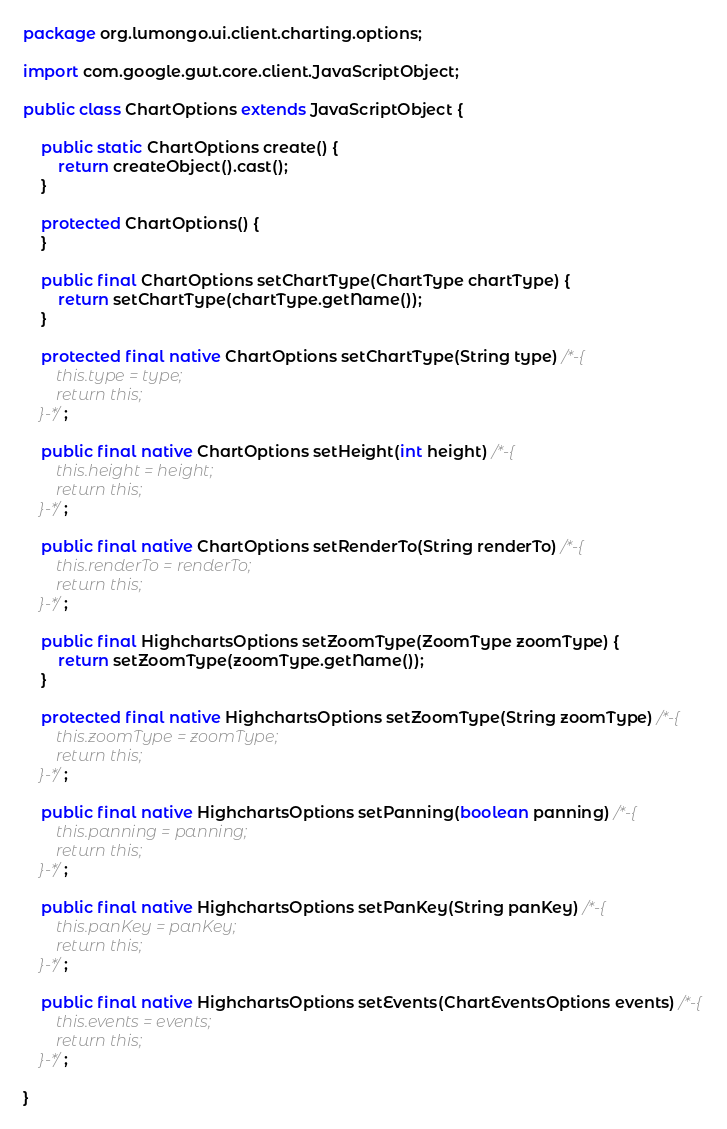Convert code to text. <code><loc_0><loc_0><loc_500><loc_500><_Java_>package org.lumongo.ui.client.charting.options;

import com.google.gwt.core.client.JavaScriptObject;

public class ChartOptions extends JavaScriptObject {

	public static ChartOptions create() {
		return createObject().cast();
	}

	protected ChartOptions() {
	}

	public final ChartOptions setChartType(ChartType chartType) {
		return setChartType(chartType.getName());
	}

	protected final native ChartOptions setChartType(String type) /*-{
        this.type = type;
        return this;
    }-*/;

	public final native ChartOptions setHeight(int height) /*-{
        this.height = height;
        return this;
    }-*/;

	public final native ChartOptions setRenderTo(String renderTo) /*-{
        this.renderTo = renderTo;
        return this;
    }-*/;

	public final HighchartsOptions setZoomType(ZoomType zoomType) {
		return setZoomType(zoomType.getName());
	}

	protected final native HighchartsOptions setZoomType(String zoomType) /*-{
        this.zoomType = zoomType;
        return this;
    }-*/;

	public final native HighchartsOptions setPanning(boolean panning) /*-{
        this.panning = panning;
        return this;
    }-*/;

	public final native HighchartsOptions setPanKey(String panKey) /*-{
        this.panKey = panKey;
        return this;
    }-*/;

	public final native HighchartsOptions setEvents(ChartEventsOptions events) /*-{
        this.events = events;
        return this;
    }-*/;

}</code> 